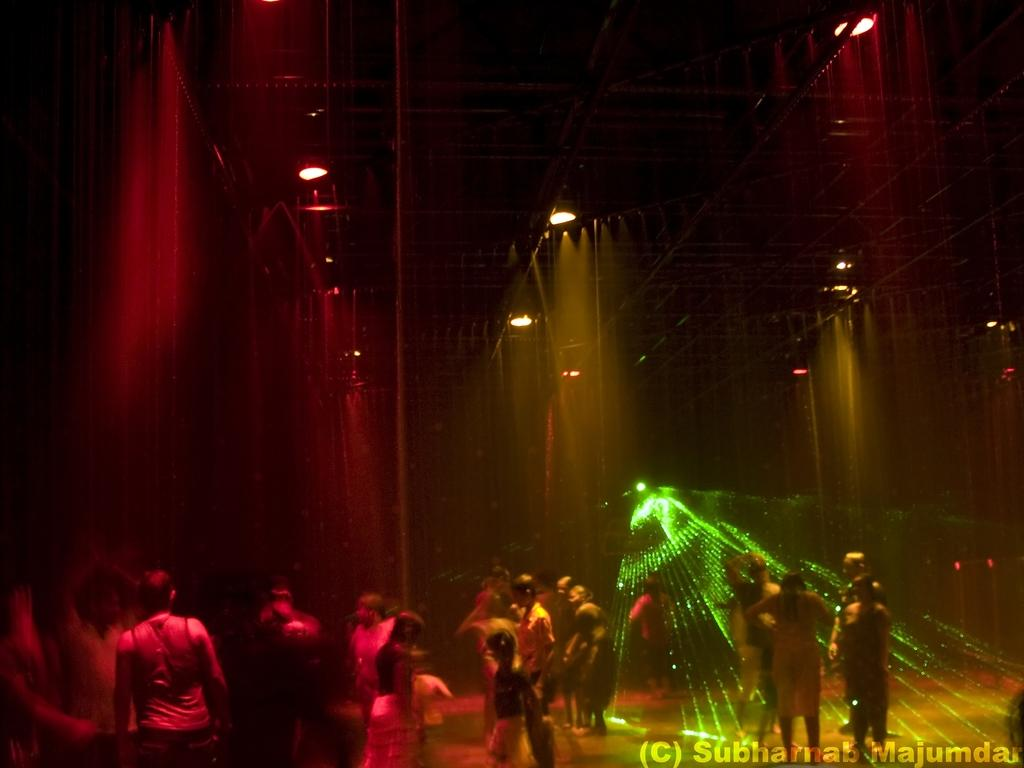What are the people in the image doing? The people in the image are standing under the shower. What structure is visible above the people in the image? There is a roof visible in the image. What can be seen providing illumination in the image? There are lights present in the image. What territory does the representative in the image represent? There is no representative present in the image; it features people standing under the shower. 